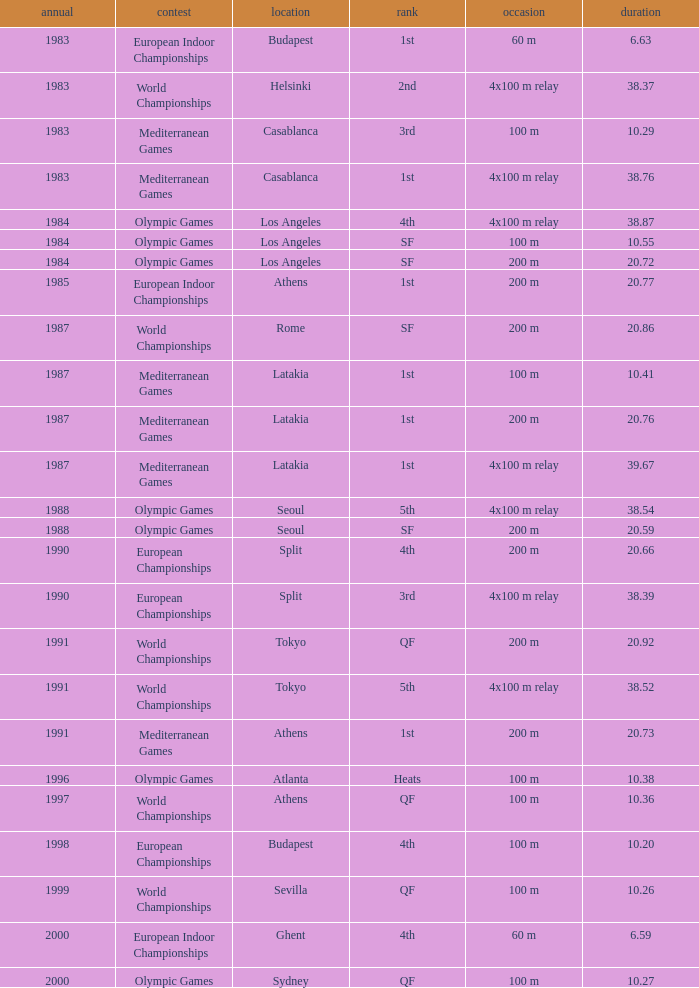What is the greatest Time with a Year of 1991, and Event of 4x100 m relay? 38.52. 